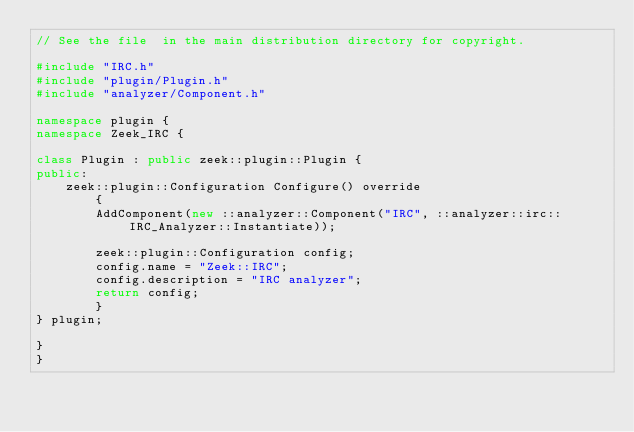Convert code to text. <code><loc_0><loc_0><loc_500><loc_500><_C++_>// See the file  in the main distribution directory for copyright.

#include "IRC.h"
#include "plugin/Plugin.h"
#include "analyzer/Component.h"

namespace plugin {
namespace Zeek_IRC {

class Plugin : public zeek::plugin::Plugin {
public:
	zeek::plugin::Configuration Configure() override
		{
		AddComponent(new ::analyzer::Component("IRC", ::analyzer::irc::IRC_Analyzer::Instantiate));

		zeek::plugin::Configuration config;
		config.name = "Zeek::IRC";
		config.description = "IRC analyzer";
		return config;
		}
} plugin;

}
}
</code> 